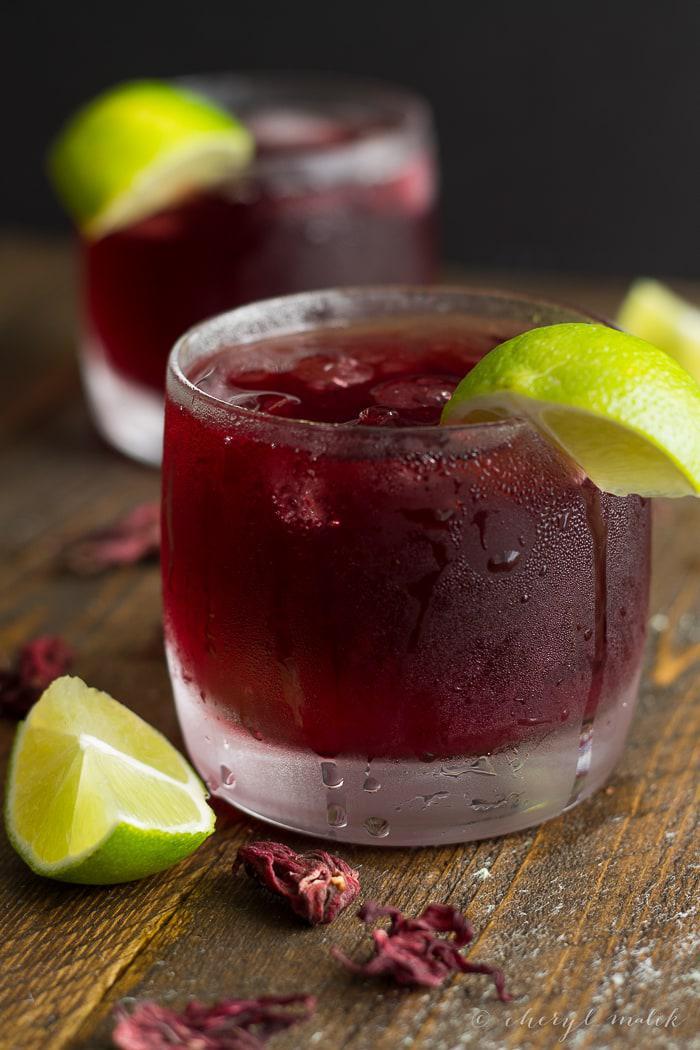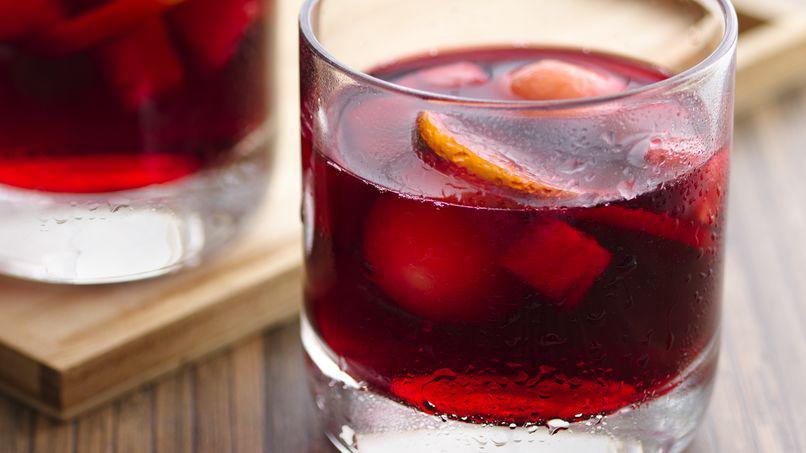The first image is the image on the left, the second image is the image on the right. Considering the images on both sides, is "Lime is used as a garnish in at least one image." valid? Answer yes or no. Yes. The first image is the image on the left, the second image is the image on the right. For the images displayed, is the sentence "At least one image shows a beverage with a lime wedge as its garnish." factually correct? Answer yes or no. Yes. 